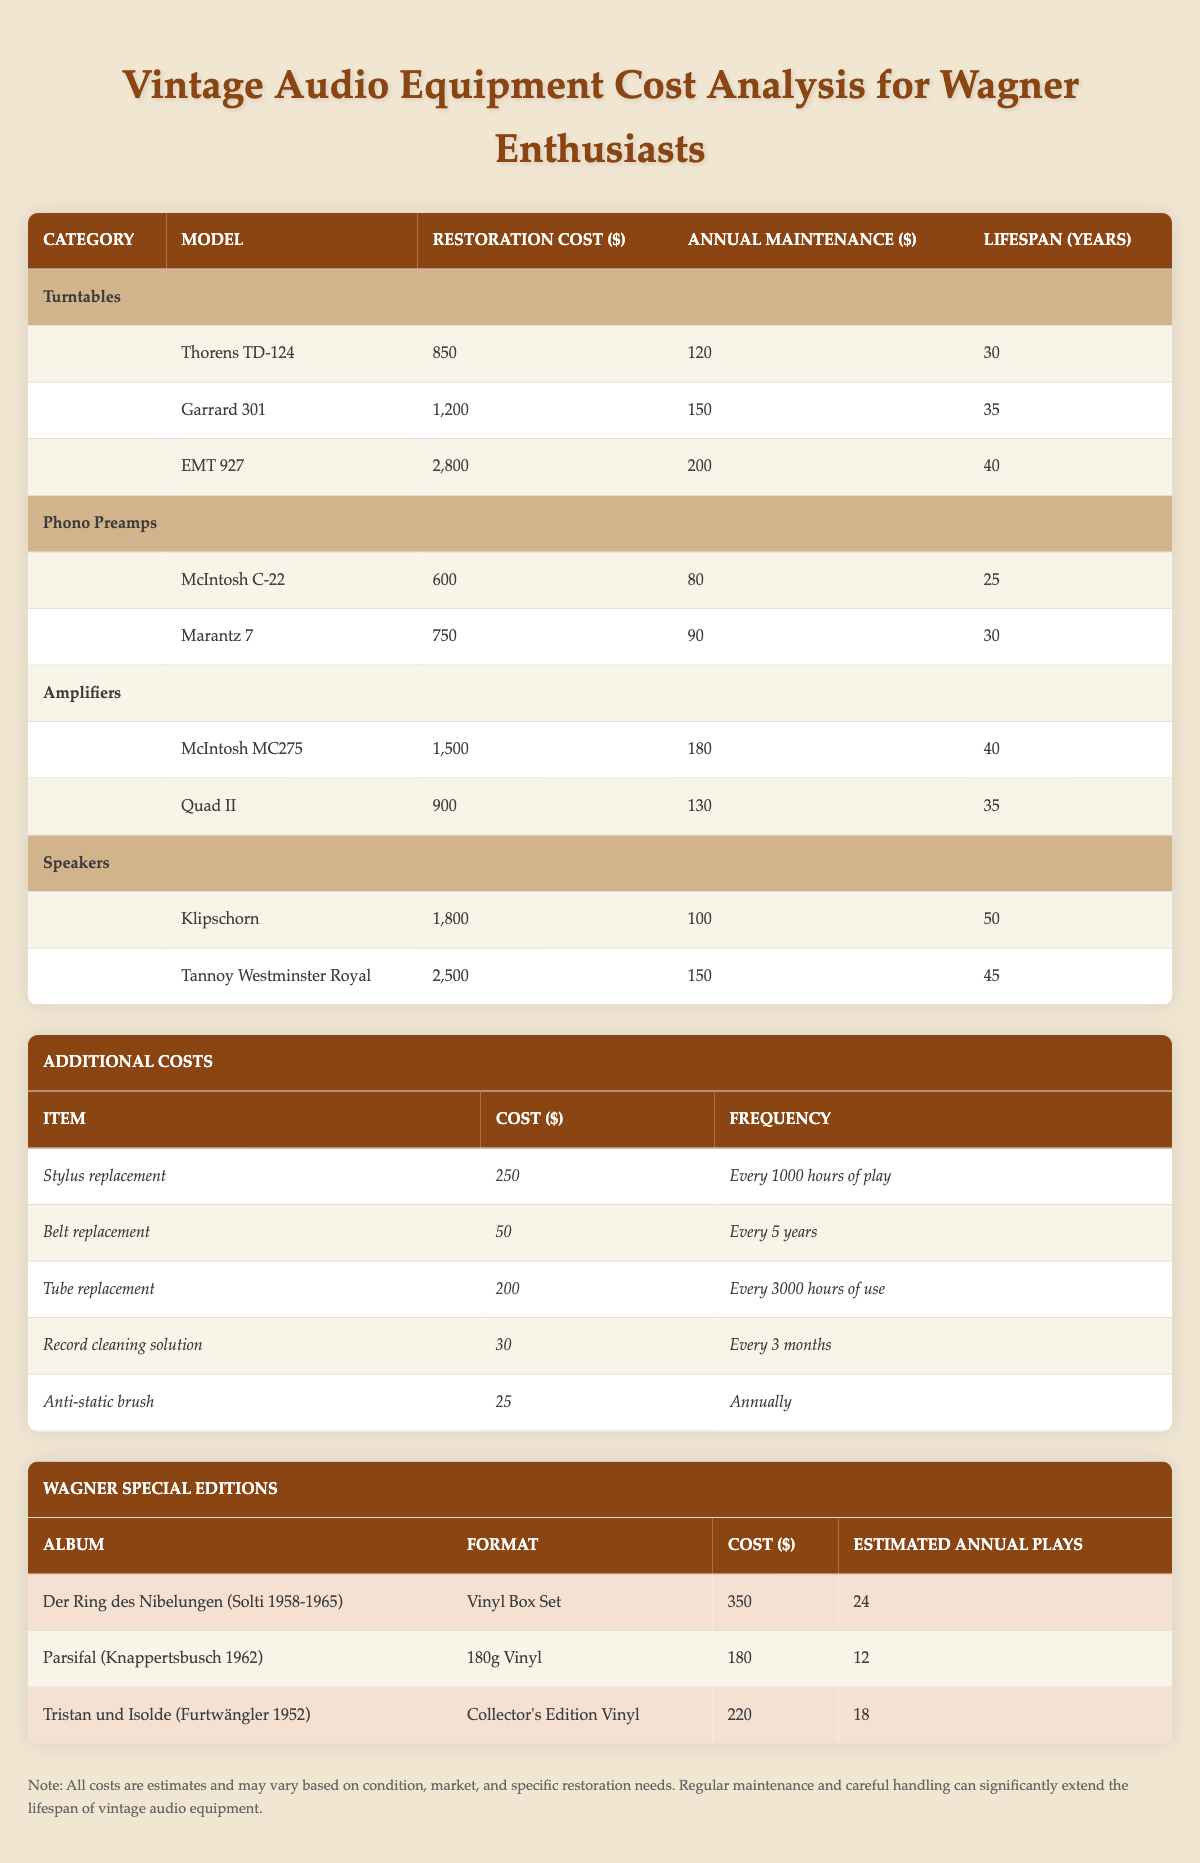What is the restoration cost of the EMT 927 turntable? The table lists the restoration cost for the EMT 927 turntable as 2800 dollars.
Answer: 2800 What is the total annual maintenance cost for all the items in the Phono Preamps category? The annual maintenance costs for the two phono preamps are 80 and 90 dollars. Summing these values gives 80 + 90 = 170 dollars as the total annual maintenance cost.
Answer: 170 Which amplifier has a longer lifespan, McIntosh MC275 or Quad II? The lifespan of McIntosh MC275 is 40 years, while Quad II has a lifespan of 35 years. Since 40 > 35, McIntosh MC275 has the longer lifespan.
Answer: McIntosh MC275 Is the annual maintenance cost for the Klipschorn speaker more than 100 dollars? The table states that the annual maintenance cost for the Klipschorn speaker is exactly 100 dollars, which means it is not more than 100 dollars.
Answer: No What is the average restoration cost for the speakers? The restoration costs for Klipschorn and Tannoy Westminster Royal are 1800 and 2500 dollars, respectively. The average is calculated as (1800 + 2500) / 2 = 2150 dollars.
Answer: 2150 How much would it cost to replace the stylus three times? The cost of stylus replacement is 250 dollars. Therefore, replacing it three times costs 250 * 3 = 750 dollars.
Answer: 750 How many estimated annual plays does the album Parsifal have compared to Tristan und Isolde? Parsifal is estimated to be played 12 times annually, while Tristan und Isolde is estimated to be played 18 times. Since 12 < 18, Parsifal has fewer estimated annual plays.
Answer: Parsifal has fewer plays What is the total cost to restore all the turntables listed? The restoration costs for the three turntables are 850, 1200, and 2800 dollars. The total restoration cost is calculated as 850 + 1200 + 2800 = 4850 dollars.
Answer: 4850 Is the combined annual maintenance cost of the Tannoy Westminster Royal and the Garrard 301 less than or equal to 300 dollars? The annual maintenance cost for Tannoy Westminster Royal is 150 dollars, and for Garrard 301, it is 150 dollars. Combined, this totals 150 + 150 = 300 dollars, which meets the condition.
Answer: Yes 